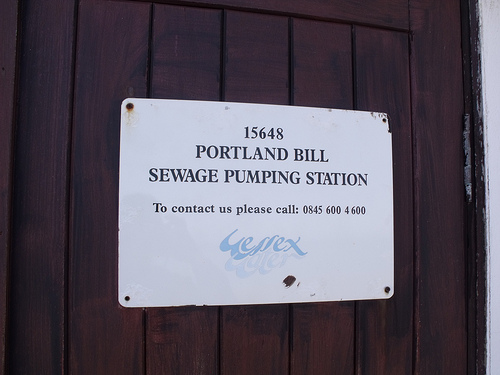<image>
Is the hinge next to the nail? No. The hinge is not positioned next to the nail. They are located in different areas of the scene. 